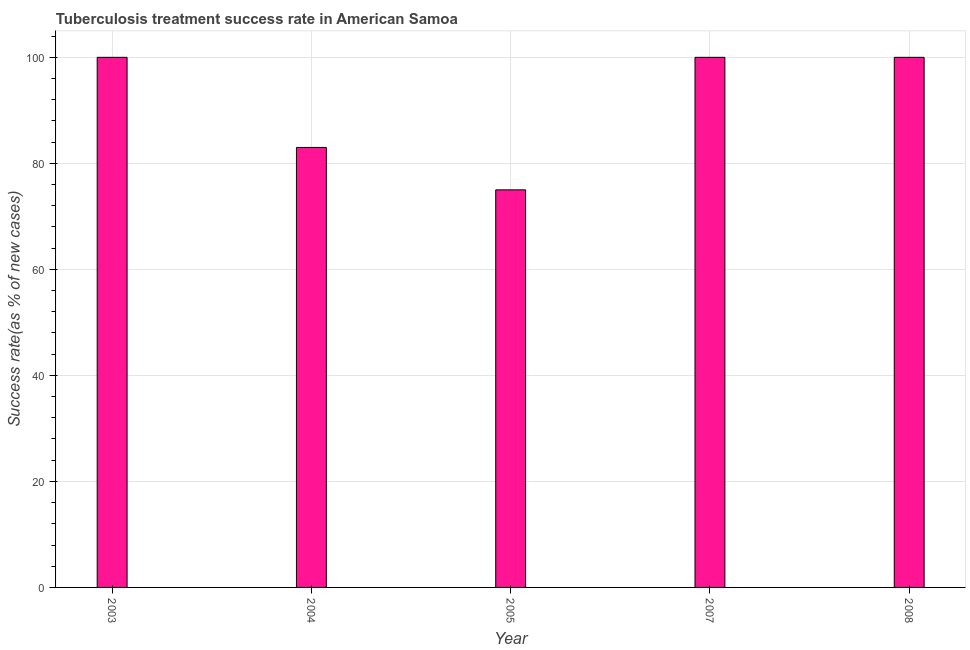Does the graph contain grids?
Offer a very short reply. Yes. What is the title of the graph?
Offer a terse response. Tuberculosis treatment success rate in American Samoa. What is the label or title of the X-axis?
Keep it short and to the point. Year. What is the label or title of the Y-axis?
Provide a short and direct response. Success rate(as % of new cases). What is the tuberculosis treatment success rate in 2007?
Provide a succinct answer. 100. Across all years, what is the maximum tuberculosis treatment success rate?
Offer a terse response. 100. In which year was the tuberculosis treatment success rate maximum?
Give a very brief answer. 2003. In which year was the tuberculosis treatment success rate minimum?
Your answer should be very brief. 2005. What is the sum of the tuberculosis treatment success rate?
Give a very brief answer. 458. What is the average tuberculosis treatment success rate per year?
Give a very brief answer. 91. In how many years, is the tuberculosis treatment success rate greater than 4 %?
Ensure brevity in your answer.  5. What is the ratio of the tuberculosis treatment success rate in 2004 to that in 2007?
Give a very brief answer. 0.83. Is the difference between the tuberculosis treatment success rate in 2004 and 2008 greater than the difference between any two years?
Provide a short and direct response. No. What is the difference between the highest and the second highest tuberculosis treatment success rate?
Offer a terse response. 0. Is the sum of the tuberculosis treatment success rate in 2004 and 2008 greater than the maximum tuberculosis treatment success rate across all years?
Your response must be concise. Yes. What is the difference between the highest and the lowest tuberculosis treatment success rate?
Offer a very short reply. 25. How many bars are there?
Your response must be concise. 5. Are all the bars in the graph horizontal?
Provide a succinct answer. No. How many years are there in the graph?
Offer a terse response. 5. What is the difference between two consecutive major ticks on the Y-axis?
Give a very brief answer. 20. Are the values on the major ticks of Y-axis written in scientific E-notation?
Your answer should be very brief. No. What is the Success rate(as % of new cases) of 2005?
Keep it short and to the point. 75. What is the Success rate(as % of new cases) in 2007?
Make the answer very short. 100. What is the Success rate(as % of new cases) of 2008?
Make the answer very short. 100. What is the difference between the Success rate(as % of new cases) in 2003 and 2004?
Keep it short and to the point. 17. What is the difference between the Success rate(as % of new cases) in 2003 and 2005?
Offer a terse response. 25. What is the difference between the Success rate(as % of new cases) in 2003 and 2007?
Give a very brief answer. 0. What is the difference between the Success rate(as % of new cases) in 2003 and 2008?
Provide a short and direct response. 0. What is the difference between the Success rate(as % of new cases) in 2005 and 2008?
Your answer should be very brief. -25. What is the ratio of the Success rate(as % of new cases) in 2003 to that in 2004?
Your answer should be very brief. 1.21. What is the ratio of the Success rate(as % of new cases) in 2003 to that in 2005?
Ensure brevity in your answer.  1.33. What is the ratio of the Success rate(as % of new cases) in 2004 to that in 2005?
Make the answer very short. 1.11. What is the ratio of the Success rate(as % of new cases) in 2004 to that in 2007?
Provide a short and direct response. 0.83. What is the ratio of the Success rate(as % of new cases) in 2004 to that in 2008?
Offer a terse response. 0.83. 